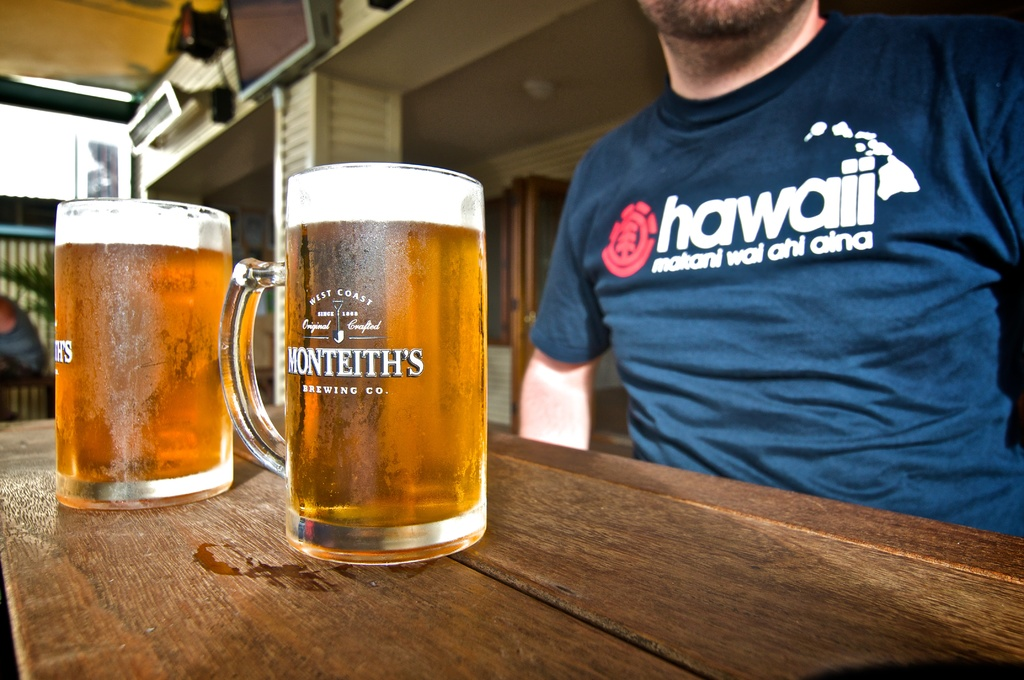What type of atmosphere does this image suggest about the location? The image suggests a casual and leisurely atmosphere, likely a pub or cafe with outdoor seating where people come to relax and enjoy a drink. 